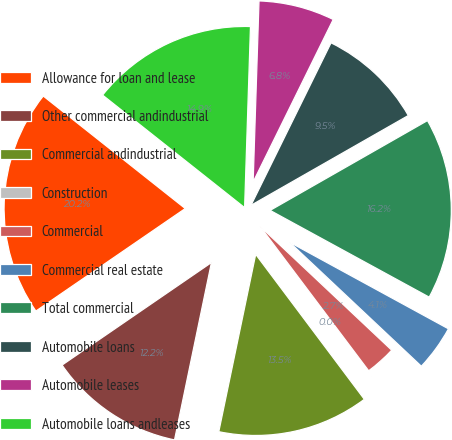Convert chart to OTSL. <chart><loc_0><loc_0><loc_500><loc_500><pie_chart><fcel>Allowance for loan and lease<fcel>Other commercial andindustrial<fcel>Commercial andindustrial<fcel>Construction<fcel>Commercial<fcel>Commercial real estate<fcel>Total commercial<fcel>Automobile loans<fcel>Automobile leases<fcel>Automobile loans andleases<nl><fcel>20.24%<fcel>12.16%<fcel>13.5%<fcel>0.03%<fcel>2.72%<fcel>4.07%<fcel>16.2%<fcel>9.46%<fcel>6.77%<fcel>14.85%<nl></chart> 